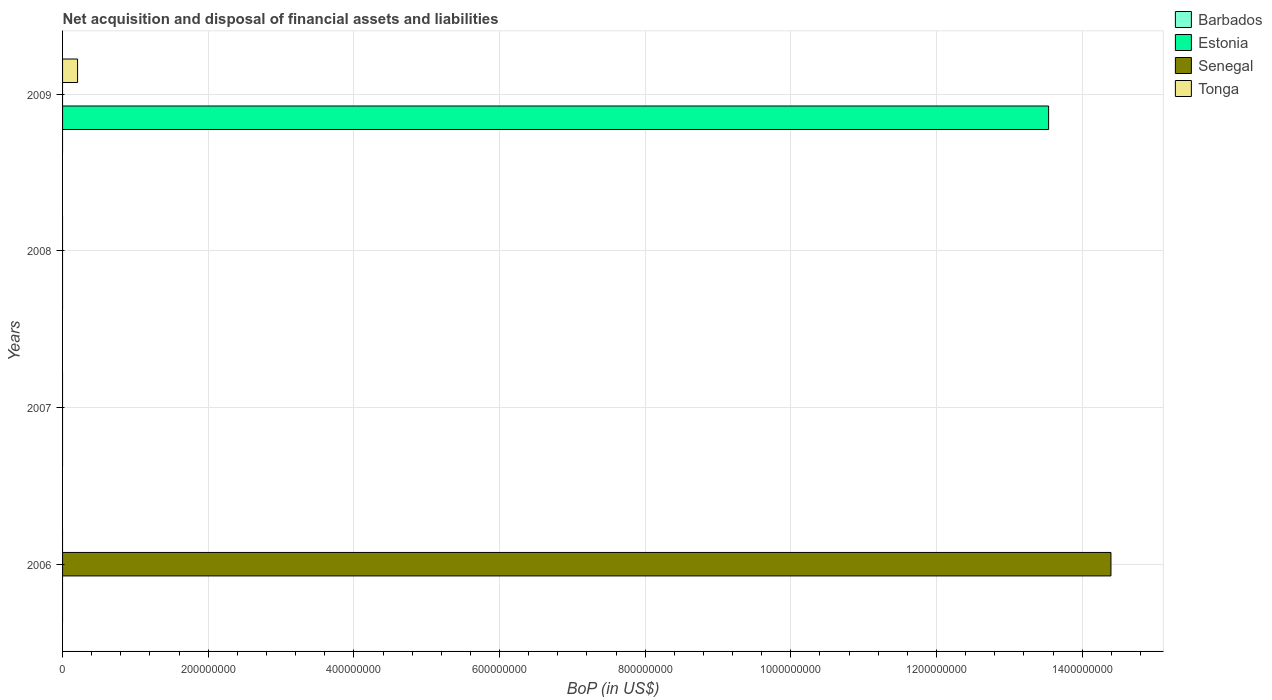Are the number of bars per tick equal to the number of legend labels?
Your answer should be very brief. No. Are the number of bars on each tick of the Y-axis equal?
Give a very brief answer. No. How many bars are there on the 3rd tick from the top?
Your response must be concise. 0. What is the label of the 2nd group of bars from the top?
Ensure brevity in your answer.  2008. What is the Balance of Payments in Estonia in 2009?
Make the answer very short. 1.35e+09. Across all years, what is the maximum Balance of Payments in Senegal?
Offer a terse response. 1.44e+09. Across all years, what is the minimum Balance of Payments in Barbados?
Give a very brief answer. 0. In which year was the Balance of Payments in Senegal maximum?
Your response must be concise. 2006. What is the total Balance of Payments in Tonga in the graph?
Keep it short and to the point. 2.06e+07. What is the difference between the Balance of Payments in Senegal in 2008 and the Balance of Payments in Barbados in 2007?
Ensure brevity in your answer.  0. What is the average Balance of Payments in Barbados per year?
Provide a succinct answer. 0. In how many years, is the Balance of Payments in Senegal greater than 120000000 US$?
Offer a very short reply. 1. What is the difference between the highest and the lowest Balance of Payments in Estonia?
Give a very brief answer. 1.35e+09. In how many years, is the Balance of Payments in Estonia greater than the average Balance of Payments in Estonia taken over all years?
Provide a succinct answer. 1. Is it the case that in every year, the sum of the Balance of Payments in Estonia and Balance of Payments in Tonga is greater than the sum of Balance of Payments in Senegal and Balance of Payments in Barbados?
Give a very brief answer. No. How many bars are there?
Make the answer very short. 3. How many years are there in the graph?
Ensure brevity in your answer.  4. Are the values on the major ticks of X-axis written in scientific E-notation?
Your response must be concise. No. Does the graph contain any zero values?
Offer a very short reply. Yes. Does the graph contain grids?
Provide a short and direct response. Yes. How many legend labels are there?
Offer a terse response. 4. How are the legend labels stacked?
Your response must be concise. Vertical. What is the title of the graph?
Make the answer very short. Net acquisition and disposal of financial assets and liabilities. Does "French Polynesia" appear as one of the legend labels in the graph?
Offer a very short reply. No. What is the label or title of the X-axis?
Your response must be concise. BoP (in US$). What is the label or title of the Y-axis?
Your answer should be compact. Years. What is the BoP (in US$) in Senegal in 2006?
Ensure brevity in your answer.  1.44e+09. What is the BoP (in US$) in Estonia in 2007?
Offer a terse response. 0. What is the BoP (in US$) of Senegal in 2007?
Offer a very short reply. 0. What is the BoP (in US$) of Tonga in 2007?
Provide a succinct answer. 0. What is the BoP (in US$) in Estonia in 2008?
Provide a succinct answer. 0. What is the BoP (in US$) in Senegal in 2008?
Make the answer very short. 0. What is the BoP (in US$) of Tonga in 2008?
Provide a short and direct response. 0. What is the BoP (in US$) in Estonia in 2009?
Provide a succinct answer. 1.35e+09. What is the BoP (in US$) in Senegal in 2009?
Give a very brief answer. 0. What is the BoP (in US$) of Tonga in 2009?
Give a very brief answer. 2.06e+07. Across all years, what is the maximum BoP (in US$) of Estonia?
Offer a very short reply. 1.35e+09. Across all years, what is the maximum BoP (in US$) in Senegal?
Give a very brief answer. 1.44e+09. Across all years, what is the maximum BoP (in US$) in Tonga?
Ensure brevity in your answer.  2.06e+07. Across all years, what is the minimum BoP (in US$) of Estonia?
Make the answer very short. 0. Across all years, what is the minimum BoP (in US$) in Tonga?
Keep it short and to the point. 0. What is the total BoP (in US$) in Barbados in the graph?
Offer a terse response. 0. What is the total BoP (in US$) in Estonia in the graph?
Offer a very short reply. 1.35e+09. What is the total BoP (in US$) of Senegal in the graph?
Provide a succinct answer. 1.44e+09. What is the total BoP (in US$) in Tonga in the graph?
Your response must be concise. 2.06e+07. What is the difference between the BoP (in US$) of Senegal in 2006 and the BoP (in US$) of Tonga in 2009?
Offer a very short reply. 1.42e+09. What is the average BoP (in US$) of Estonia per year?
Your response must be concise. 3.38e+08. What is the average BoP (in US$) of Senegal per year?
Make the answer very short. 3.60e+08. What is the average BoP (in US$) in Tonga per year?
Offer a terse response. 5.15e+06. In the year 2009, what is the difference between the BoP (in US$) in Estonia and BoP (in US$) in Tonga?
Provide a succinct answer. 1.33e+09. What is the difference between the highest and the lowest BoP (in US$) in Estonia?
Provide a succinct answer. 1.35e+09. What is the difference between the highest and the lowest BoP (in US$) of Senegal?
Give a very brief answer. 1.44e+09. What is the difference between the highest and the lowest BoP (in US$) of Tonga?
Ensure brevity in your answer.  2.06e+07. 